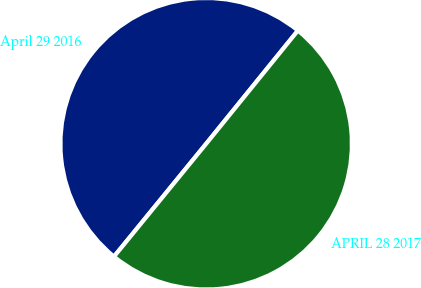Convert chart to OTSL. <chart><loc_0><loc_0><loc_500><loc_500><pie_chart><fcel>April 29 2016<fcel>APRIL 28 2017<nl><fcel>49.94%<fcel>50.06%<nl></chart> 